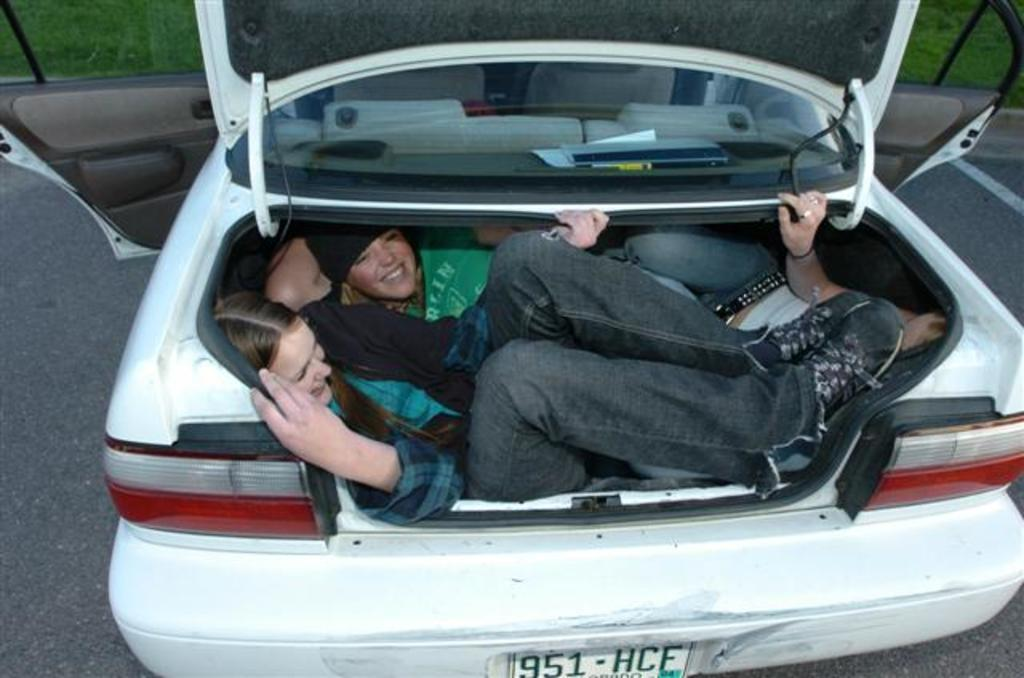Where was the image taken? The image is taken outdoors. What is happening in the image? There is a group of people in the image, and they are lying on a car. What color is the car? The car is white. What is visible in the background of the car? The background of the car is grass. What book is the person reading while lying on the car? There is no person reading a book in the image; the people are lying on the car without any visible reading material. 